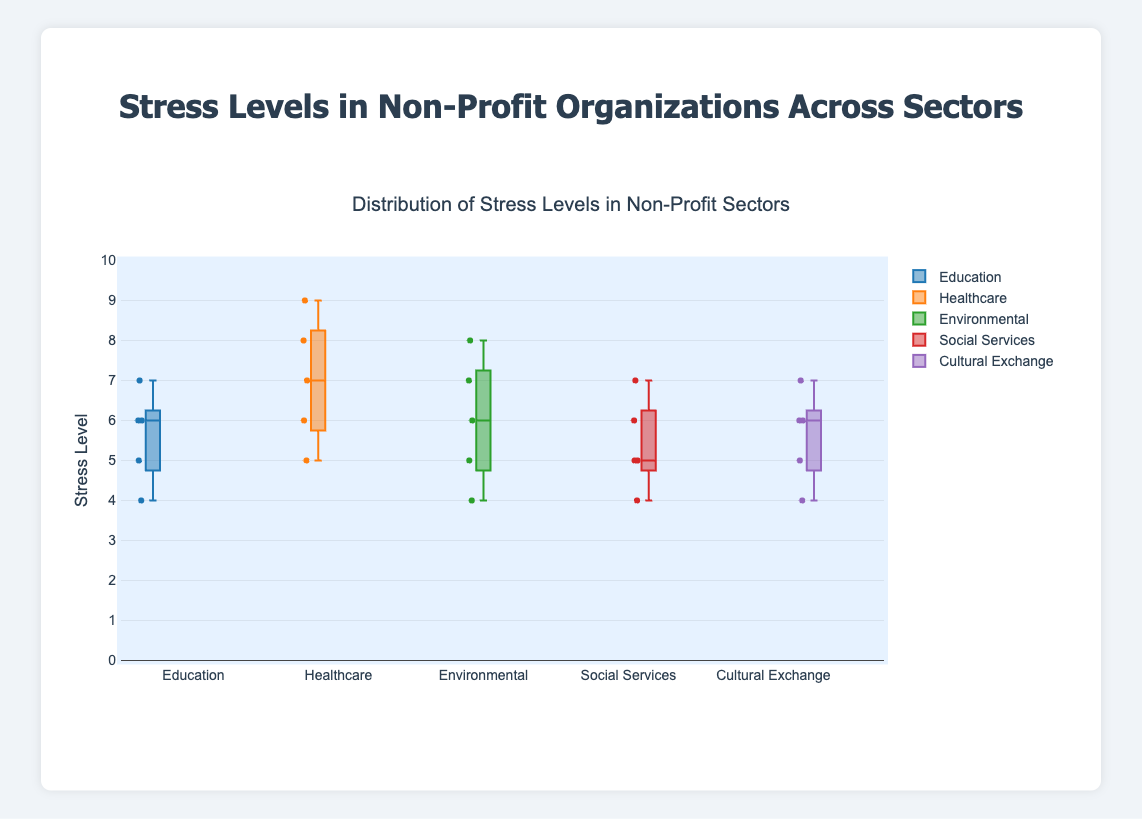What is the title of the figure? The title of the figure is displayed at the top center of the box plot.
Answer: Distribution of Stress Levels in Non-Profit Sectors What is the range of the y-axis? The y-axis range is specified in the y-axis settings and is visible along the vertical axis.
Answer: 0 to 10 Which sector has the highest median stress level? Locate the median line (the line inside the box) for each sector's box plot and identify the one at the highest position.
Answer: Healthcare Which sector has the lowest median stress level? Locate the median line for each sector's box plot and identify the one at the lowest position.
Answer: Social Services How many stress levels were reported in the Education sector? Count the number of points in the Education sector's box plot.
Answer: 5 What is the interquartile range (IQR) for the Healthcare sector? The IQR is the difference between the third quartile (top of the box) and the first quartile (bottom of the box) in the Healthcare sector's box plot.
Answer: 2 (8 - 6) Which sector shows a wider range of stress levels, Environmental or Cultural Exchange? Compare the range (difference between max and min points) of the two sectors' box plots to determine which is wider.
Answer: Environmental What is the median stress level for the Social Services sector? The median stress level is the middle line inside the box for the Social Services sector.
Answer: 5 What is the highest reported stress level in the Environmental sector? The highest reported stress level is the maximum point in the Environmental sector's box plot.
Answer: 8 Compare the median stress levels of Education and Cultural Exchange sectors. Which is higher? Find and compare the median lines (middle lines inside the boxes) of both sectors.
Answer: They are the same 